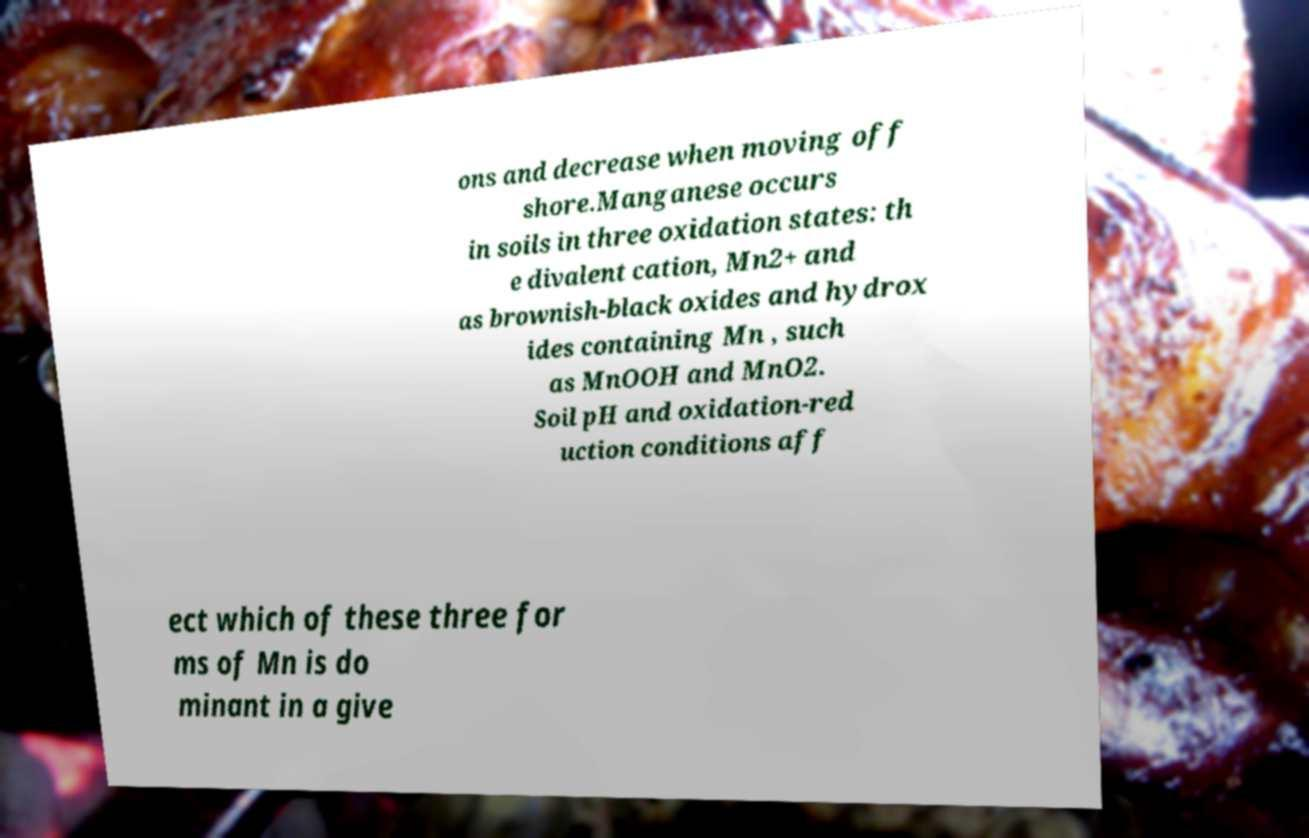What messages or text are displayed in this image? I need them in a readable, typed format. ons and decrease when moving off shore.Manganese occurs in soils in three oxidation states: th e divalent cation, Mn2+ and as brownish-black oxides and hydrox ides containing Mn , such as MnOOH and MnO2. Soil pH and oxidation-red uction conditions aff ect which of these three for ms of Mn is do minant in a give 